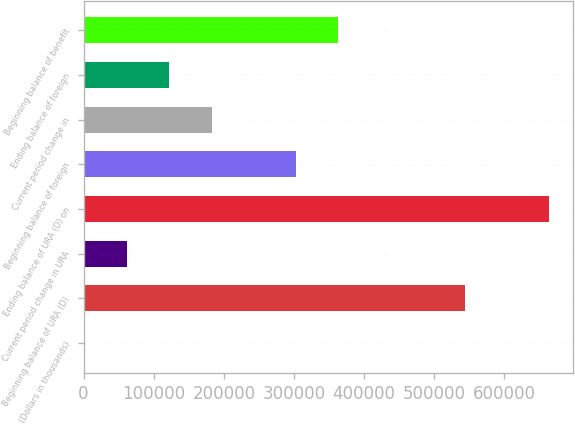Convert chart to OTSL. <chart><loc_0><loc_0><loc_500><loc_500><bar_chart><fcel>(Dollars in thousands)<fcel>Beginning balance of URA (D)<fcel>Current period change in URA<fcel>Ending balance of URA (D) on<fcel>Beginning balance of foreign<fcel>Current period change in<fcel>Ending balance of foreign<fcel>Beginning balance of benefit<nl><fcel>2012<fcel>543736<fcel>62203.6<fcel>664120<fcel>302970<fcel>182587<fcel>122395<fcel>363162<nl></chart> 